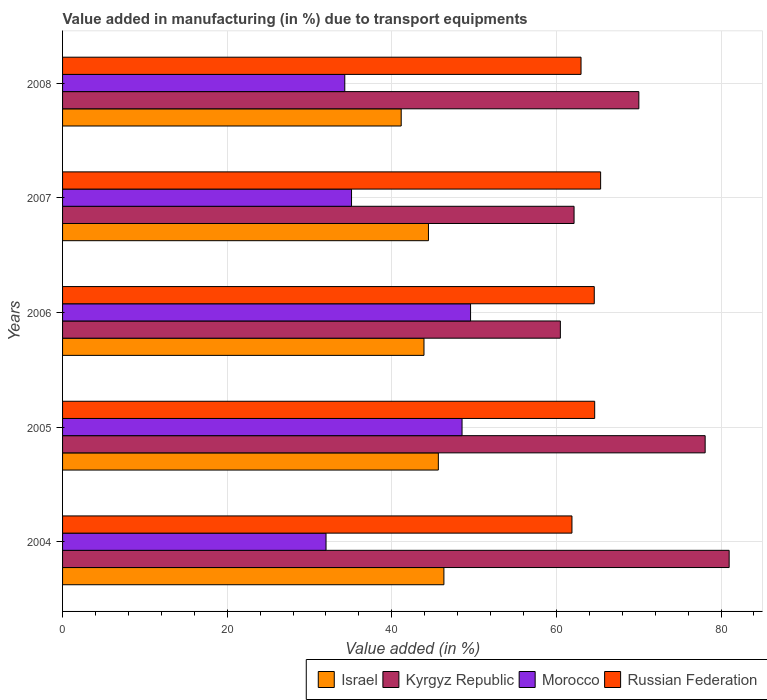Are the number of bars on each tick of the Y-axis equal?
Give a very brief answer. Yes. How many bars are there on the 1st tick from the bottom?
Give a very brief answer. 4. What is the label of the 5th group of bars from the top?
Your answer should be very brief. 2004. In how many cases, is the number of bars for a given year not equal to the number of legend labels?
Give a very brief answer. 0. What is the percentage of value added in manufacturing due to transport equipments in Morocco in 2006?
Provide a short and direct response. 49.57. Across all years, what is the maximum percentage of value added in manufacturing due to transport equipments in Israel?
Ensure brevity in your answer.  46.33. Across all years, what is the minimum percentage of value added in manufacturing due to transport equipments in Russian Federation?
Give a very brief answer. 61.89. What is the total percentage of value added in manufacturing due to transport equipments in Kyrgyz Republic in the graph?
Ensure brevity in your answer.  351.68. What is the difference between the percentage of value added in manufacturing due to transport equipments in Israel in 2007 and that in 2008?
Your response must be concise. 3.31. What is the difference between the percentage of value added in manufacturing due to transport equipments in Russian Federation in 2004 and the percentage of value added in manufacturing due to transport equipments in Kyrgyz Republic in 2005?
Your response must be concise. -16.18. What is the average percentage of value added in manufacturing due to transport equipments in Russian Federation per year?
Give a very brief answer. 63.9. In the year 2004, what is the difference between the percentage of value added in manufacturing due to transport equipments in Morocco and percentage of value added in manufacturing due to transport equipments in Kyrgyz Republic?
Keep it short and to the point. -48.98. What is the ratio of the percentage of value added in manufacturing due to transport equipments in Israel in 2004 to that in 2008?
Provide a succinct answer. 1.13. Is the percentage of value added in manufacturing due to transport equipments in Morocco in 2004 less than that in 2007?
Make the answer very short. Yes. What is the difference between the highest and the second highest percentage of value added in manufacturing due to transport equipments in Morocco?
Offer a terse response. 1.03. What is the difference between the highest and the lowest percentage of value added in manufacturing due to transport equipments in Kyrgyz Republic?
Provide a short and direct response. 20.51. Is the sum of the percentage of value added in manufacturing due to transport equipments in Kyrgyz Republic in 2004 and 2006 greater than the maximum percentage of value added in manufacturing due to transport equipments in Israel across all years?
Your response must be concise. Yes. What does the 1st bar from the top in 2005 represents?
Your response must be concise. Russian Federation. What does the 2nd bar from the bottom in 2008 represents?
Offer a terse response. Kyrgyz Republic. Is it the case that in every year, the sum of the percentage of value added in manufacturing due to transport equipments in Kyrgyz Republic and percentage of value added in manufacturing due to transport equipments in Russian Federation is greater than the percentage of value added in manufacturing due to transport equipments in Israel?
Provide a succinct answer. Yes. Where does the legend appear in the graph?
Offer a very short reply. Bottom right. What is the title of the graph?
Your answer should be compact. Value added in manufacturing (in %) due to transport equipments. Does "Jordan" appear as one of the legend labels in the graph?
Keep it short and to the point. No. What is the label or title of the X-axis?
Provide a succinct answer. Value added (in %). What is the label or title of the Y-axis?
Make the answer very short. Years. What is the Value added (in %) in Israel in 2004?
Offer a terse response. 46.33. What is the Value added (in %) of Kyrgyz Republic in 2004?
Your answer should be compact. 80.98. What is the Value added (in %) of Morocco in 2004?
Provide a succinct answer. 32.01. What is the Value added (in %) in Russian Federation in 2004?
Make the answer very short. 61.89. What is the Value added (in %) in Israel in 2005?
Keep it short and to the point. 45.65. What is the Value added (in %) of Kyrgyz Republic in 2005?
Make the answer very short. 78.07. What is the Value added (in %) in Morocco in 2005?
Your answer should be very brief. 48.53. What is the Value added (in %) in Russian Federation in 2005?
Your answer should be very brief. 64.65. What is the Value added (in %) of Israel in 2006?
Provide a succinct answer. 43.91. What is the Value added (in %) in Kyrgyz Republic in 2006?
Ensure brevity in your answer.  60.48. What is the Value added (in %) in Morocco in 2006?
Keep it short and to the point. 49.57. What is the Value added (in %) of Russian Federation in 2006?
Give a very brief answer. 64.59. What is the Value added (in %) in Israel in 2007?
Ensure brevity in your answer.  44.45. What is the Value added (in %) of Kyrgyz Republic in 2007?
Provide a short and direct response. 62.14. What is the Value added (in %) of Morocco in 2007?
Offer a terse response. 35.11. What is the Value added (in %) of Russian Federation in 2007?
Offer a very short reply. 65.37. What is the Value added (in %) of Israel in 2008?
Offer a terse response. 41.14. What is the Value added (in %) in Kyrgyz Republic in 2008?
Offer a very short reply. 70.01. What is the Value added (in %) in Morocco in 2008?
Make the answer very short. 34.29. What is the Value added (in %) in Russian Federation in 2008?
Offer a very short reply. 62.99. Across all years, what is the maximum Value added (in %) in Israel?
Offer a very short reply. 46.33. Across all years, what is the maximum Value added (in %) in Kyrgyz Republic?
Make the answer very short. 80.98. Across all years, what is the maximum Value added (in %) in Morocco?
Keep it short and to the point. 49.57. Across all years, what is the maximum Value added (in %) in Russian Federation?
Offer a very short reply. 65.37. Across all years, what is the minimum Value added (in %) in Israel?
Keep it short and to the point. 41.14. Across all years, what is the minimum Value added (in %) of Kyrgyz Republic?
Ensure brevity in your answer.  60.48. Across all years, what is the minimum Value added (in %) in Morocco?
Keep it short and to the point. 32.01. Across all years, what is the minimum Value added (in %) of Russian Federation?
Make the answer very short. 61.89. What is the total Value added (in %) of Israel in the graph?
Your answer should be very brief. 221.48. What is the total Value added (in %) of Kyrgyz Republic in the graph?
Ensure brevity in your answer.  351.68. What is the total Value added (in %) in Morocco in the graph?
Provide a succinct answer. 199.5. What is the total Value added (in %) in Russian Federation in the graph?
Give a very brief answer. 319.48. What is the difference between the Value added (in %) of Israel in 2004 and that in 2005?
Keep it short and to the point. 0.67. What is the difference between the Value added (in %) in Kyrgyz Republic in 2004 and that in 2005?
Offer a very short reply. 2.92. What is the difference between the Value added (in %) in Morocco in 2004 and that in 2005?
Make the answer very short. -16.52. What is the difference between the Value added (in %) in Russian Federation in 2004 and that in 2005?
Your response must be concise. -2.76. What is the difference between the Value added (in %) in Israel in 2004 and that in 2006?
Provide a succinct answer. 2.42. What is the difference between the Value added (in %) in Kyrgyz Republic in 2004 and that in 2006?
Offer a very short reply. 20.51. What is the difference between the Value added (in %) of Morocco in 2004 and that in 2006?
Give a very brief answer. -17.56. What is the difference between the Value added (in %) in Russian Federation in 2004 and that in 2006?
Make the answer very short. -2.71. What is the difference between the Value added (in %) of Israel in 2004 and that in 2007?
Offer a very short reply. 1.88. What is the difference between the Value added (in %) of Kyrgyz Republic in 2004 and that in 2007?
Make the answer very short. 18.84. What is the difference between the Value added (in %) of Morocco in 2004 and that in 2007?
Ensure brevity in your answer.  -3.1. What is the difference between the Value added (in %) of Russian Federation in 2004 and that in 2007?
Your response must be concise. -3.48. What is the difference between the Value added (in %) in Israel in 2004 and that in 2008?
Offer a terse response. 5.19. What is the difference between the Value added (in %) in Kyrgyz Republic in 2004 and that in 2008?
Provide a short and direct response. 10.97. What is the difference between the Value added (in %) of Morocco in 2004 and that in 2008?
Keep it short and to the point. -2.28. What is the difference between the Value added (in %) of Russian Federation in 2004 and that in 2008?
Keep it short and to the point. -1.1. What is the difference between the Value added (in %) of Israel in 2005 and that in 2006?
Offer a terse response. 1.75. What is the difference between the Value added (in %) in Kyrgyz Republic in 2005 and that in 2006?
Offer a terse response. 17.59. What is the difference between the Value added (in %) of Morocco in 2005 and that in 2006?
Make the answer very short. -1.03. What is the difference between the Value added (in %) in Russian Federation in 2005 and that in 2006?
Provide a short and direct response. 0.05. What is the difference between the Value added (in %) in Israel in 2005 and that in 2007?
Your answer should be compact. 1.2. What is the difference between the Value added (in %) in Kyrgyz Republic in 2005 and that in 2007?
Ensure brevity in your answer.  15.93. What is the difference between the Value added (in %) of Morocco in 2005 and that in 2007?
Your response must be concise. 13.43. What is the difference between the Value added (in %) of Russian Federation in 2005 and that in 2007?
Offer a very short reply. -0.72. What is the difference between the Value added (in %) in Israel in 2005 and that in 2008?
Your answer should be very brief. 4.51. What is the difference between the Value added (in %) in Kyrgyz Republic in 2005 and that in 2008?
Your answer should be compact. 8.06. What is the difference between the Value added (in %) of Morocco in 2005 and that in 2008?
Your answer should be very brief. 14.25. What is the difference between the Value added (in %) in Russian Federation in 2005 and that in 2008?
Ensure brevity in your answer.  1.66. What is the difference between the Value added (in %) of Israel in 2006 and that in 2007?
Make the answer very short. -0.54. What is the difference between the Value added (in %) of Kyrgyz Republic in 2006 and that in 2007?
Offer a terse response. -1.67. What is the difference between the Value added (in %) in Morocco in 2006 and that in 2007?
Keep it short and to the point. 14.46. What is the difference between the Value added (in %) in Russian Federation in 2006 and that in 2007?
Your response must be concise. -0.77. What is the difference between the Value added (in %) in Israel in 2006 and that in 2008?
Keep it short and to the point. 2.77. What is the difference between the Value added (in %) in Kyrgyz Republic in 2006 and that in 2008?
Your answer should be compact. -9.54. What is the difference between the Value added (in %) in Morocco in 2006 and that in 2008?
Offer a very short reply. 15.28. What is the difference between the Value added (in %) of Russian Federation in 2006 and that in 2008?
Your answer should be compact. 1.61. What is the difference between the Value added (in %) of Israel in 2007 and that in 2008?
Provide a succinct answer. 3.31. What is the difference between the Value added (in %) in Kyrgyz Republic in 2007 and that in 2008?
Offer a very short reply. -7.87. What is the difference between the Value added (in %) of Morocco in 2007 and that in 2008?
Your answer should be compact. 0.82. What is the difference between the Value added (in %) of Russian Federation in 2007 and that in 2008?
Provide a succinct answer. 2.38. What is the difference between the Value added (in %) of Israel in 2004 and the Value added (in %) of Kyrgyz Republic in 2005?
Provide a succinct answer. -31.74. What is the difference between the Value added (in %) in Israel in 2004 and the Value added (in %) in Morocco in 2005?
Make the answer very short. -2.2. What is the difference between the Value added (in %) in Israel in 2004 and the Value added (in %) in Russian Federation in 2005?
Your answer should be compact. -18.32. What is the difference between the Value added (in %) in Kyrgyz Republic in 2004 and the Value added (in %) in Morocco in 2005?
Ensure brevity in your answer.  32.45. What is the difference between the Value added (in %) of Kyrgyz Republic in 2004 and the Value added (in %) of Russian Federation in 2005?
Your answer should be very brief. 16.34. What is the difference between the Value added (in %) of Morocco in 2004 and the Value added (in %) of Russian Federation in 2005?
Your response must be concise. -32.64. What is the difference between the Value added (in %) of Israel in 2004 and the Value added (in %) of Kyrgyz Republic in 2006?
Offer a terse response. -14.15. What is the difference between the Value added (in %) in Israel in 2004 and the Value added (in %) in Morocco in 2006?
Give a very brief answer. -3.24. What is the difference between the Value added (in %) in Israel in 2004 and the Value added (in %) in Russian Federation in 2006?
Offer a very short reply. -18.27. What is the difference between the Value added (in %) in Kyrgyz Republic in 2004 and the Value added (in %) in Morocco in 2006?
Your answer should be compact. 31.42. What is the difference between the Value added (in %) in Kyrgyz Republic in 2004 and the Value added (in %) in Russian Federation in 2006?
Ensure brevity in your answer.  16.39. What is the difference between the Value added (in %) in Morocco in 2004 and the Value added (in %) in Russian Federation in 2006?
Provide a short and direct response. -32.59. What is the difference between the Value added (in %) of Israel in 2004 and the Value added (in %) of Kyrgyz Republic in 2007?
Ensure brevity in your answer.  -15.81. What is the difference between the Value added (in %) of Israel in 2004 and the Value added (in %) of Morocco in 2007?
Your answer should be compact. 11.22. What is the difference between the Value added (in %) in Israel in 2004 and the Value added (in %) in Russian Federation in 2007?
Your answer should be very brief. -19.04. What is the difference between the Value added (in %) of Kyrgyz Republic in 2004 and the Value added (in %) of Morocco in 2007?
Offer a terse response. 45.88. What is the difference between the Value added (in %) of Kyrgyz Republic in 2004 and the Value added (in %) of Russian Federation in 2007?
Your answer should be very brief. 15.62. What is the difference between the Value added (in %) in Morocco in 2004 and the Value added (in %) in Russian Federation in 2007?
Your answer should be compact. -33.36. What is the difference between the Value added (in %) of Israel in 2004 and the Value added (in %) of Kyrgyz Republic in 2008?
Make the answer very short. -23.68. What is the difference between the Value added (in %) of Israel in 2004 and the Value added (in %) of Morocco in 2008?
Your response must be concise. 12.04. What is the difference between the Value added (in %) in Israel in 2004 and the Value added (in %) in Russian Federation in 2008?
Provide a succinct answer. -16.66. What is the difference between the Value added (in %) of Kyrgyz Republic in 2004 and the Value added (in %) of Morocco in 2008?
Make the answer very short. 46.7. What is the difference between the Value added (in %) of Kyrgyz Republic in 2004 and the Value added (in %) of Russian Federation in 2008?
Provide a succinct answer. 18. What is the difference between the Value added (in %) of Morocco in 2004 and the Value added (in %) of Russian Federation in 2008?
Keep it short and to the point. -30.98. What is the difference between the Value added (in %) of Israel in 2005 and the Value added (in %) of Kyrgyz Republic in 2006?
Offer a terse response. -14.82. What is the difference between the Value added (in %) in Israel in 2005 and the Value added (in %) in Morocco in 2006?
Your answer should be compact. -3.91. What is the difference between the Value added (in %) of Israel in 2005 and the Value added (in %) of Russian Federation in 2006?
Ensure brevity in your answer.  -18.94. What is the difference between the Value added (in %) of Kyrgyz Republic in 2005 and the Value added (in %) of Morocco in 2006?
Your answer should be compact. 28.5. What is the difference between the Value added (in %) in Kyrgyz Republic in 2005 and the Value added (in %) in Russian Federation in 2006?
Make the answer very short. 13.47. What is the difference between the Value added (in %) of Morocco in 2005 and the Value added (in %) of Russian Federation in 2006?
Make the answer very short. -16.06. What is the difference between the Value added (in %) in Israel in 2005 and the Value added (in %) in Kyrgyz Republic in 2007?
Provide a short and direct response. -16.49. What is the difference between the Value added (in %) in Israel in 2005 and the Value added (in %) in Morocco in 2007?
Your response must be concise. 10.55. What is the difference between the Value added (in %) in Israel in 2005 and the Value added (in %) in Russian Federation in 2007?
Your response must be concise. -19.71. What is the difference between the Value added (in %) of Kyrgyz Republic in 2005 and the Value added (in %) of Morocco in 2007?
Provide a succinct answer. 42.96. What is the difference between the Value added (in %) of Kyrgyz Republic in 2005 and the Value added (in %) of Russian Federation in 2007?
Provide a succinct answer. 12.7. What is the difference between the Value added (in %) of Morocco in 2005 and the Value added (in %) of Russian Federation in 2007?
Provide a short and direct response. -16.84. What is the difference between the Value added (in %) of Israel in 2005 and the Value added (in %) of Kyrgyz Republic in 2008?
Give a very brief answer. -24.36. What is the difference between the Value added (in %) of Israel in 2005 and the Value added (in %) of Morocco in 2008?
Offer a very short reply. 11.37. What is the difference between the Value added (in %) of Israel in 2005 and the Value added (in %) of Russian Federation in 2008?
Your response must be concise. -17.34. What is the difference between the Value added (in %) in Kyrgyz Republic in 2005 and the Value added (in %) in Morocco in 2008?
Offer a terse response. 43.78. What is the difference between the Value added (in %) in Kyrgyz Republic in 2005 and the Value added (in %) in Russian Federation in 2008?
Provide a succinct answer. 15.08. What is the difference between the Value added (in %) of Morocco in 2005 and the Value added (in %) of Russian Federation in 2008?
Provide a short and direct response. -14.46. What is the difference between the Value added (in %) in Israel in 2006 and the Value added (in %) in Kyrgyz Republic in 2007?
Offer a very short reply. -18.23. What is the difference between the Value added (in %) of Israel in 2006 and the Value added (in %) of Morocco in 2007?
Keep it short and to the point. 8.8. What is the difference between the Value added (in %) in Israel in 2006 and the Value added (in %) in Russian Federation in 2007?
Your response must be concise. -21.46. What is the difference between the Value added (in %) in Kyrgyz Republic in 2006 and the Value added (in %) in Morocco in 2007?
Offer a terse response. 25.37. What is the difference between the Value added (in %) of Kyrgyz Republic in 2006 and the Value added (in %) of Russian Federation in 2007?
Provide a succinct answer. -4.89. What is the difference between the Value added (in %) of Morocco in 2006 and the Value added (in %) of Russian Federation in 2007?
Keep it short and to the point. -15.8. What is the difference between the Value added (in %) of Israel in 2006 and the Value added (in %) of Kyrgyz Republic in 2008?
Your answer should be compact. -26.1. What is the difference between the Value added (in %) of Israel in 2006 and the Value added (in %) of Morocco in 2008?
Your response must be concise. 9.62. What is the difference between the Value added (in %) in Israel in 2006 and the Value added (in %) in Russian Federation in 2008?
Offer a terse response. -19.08. What is the difference between the Value added (in %) in Kyrgyz Republic in 2006 and the Value added (in %) in Morocco in 2008?
Offer a terse response. 26.19. What is the difference between the Value added (in %) of Kyrgyz Republic in 2006 and the Value added (in %) of Russian Federation in 2008?
Your response must be concise. -2.51. What is the difference between the Value added (in %) in Morocco in 2006 and the Value added (in %) in Russian Federation in 2008?
Give a very brief answer. -13.42. What is the difference between the Value added (in %) in Israel in 2007 and the Value added (in %) in Kyrgyz Republic in 2008?
Keep it short and to the point. -25.56. What is the difference between the Value added (in %) in Israel in 2007 and the Value added (in %) in Morocco in 2008?
Keep it short and to the point. 10.16. What is the difference between the Value added (in %) in Israel in 2007 and the Value added (in %) in Russian Federation in 2008?
Your answer should be very brief. -18.54. What is the difference between the Value added (in %) in Kyrgyz Republic in 2007 and the Value added (in %) in Morocco in 2008?
Offer a terse response. 27.86. What is the difference between the Value added (in %) in Kyrgyz Republic in 2007 and the Value added (in %) in Russian Federation in 2008?
Make the answer very short. -0.85. What is the difference between the Value added (in %) in Morocco in 2007 and the Value added (in %) in Russian Federation in 2008?
Give a very brief answer. -27.88. What is the average Value added (in %) in Israel per year?
Ensure brevity in your answer.  44.3. What is the average Value added (in %) of Kyrgyz Republic per year?
Your answer should be compact. 70.34. What is the average Value added (in %) of Morocco per year?
Your answer should be compact. 39.9. What is the average Value added (in %) in Russian Federation per year?
Your answer should be compact. 63.9. In the year 2004, what is the difference between the Value added (in %) in Israel and Value added (in %) in Kyrgyz Republic?
Keep it short and to the point. -34.66. In the year 2004, what is the difference between the Value added (in %) of Israel and Value added (in %) of Morocco?
Provide a succinct answer. 14.32. In the year 2004, what is the difference between the Value added (in %) in Israel and Value added (in %) in Russian Federation?
Make the answer very short. -15.56. In the year 2004, what is the difference between the Value added (in %) of Kyrgyz Republic and Value added (in %) of Morocco?
Ensure brevity in your answer.  48.98. In the year 2004, what is the difference between the Value added (in %) in Kyrgyz Republic and Value added (in %) in Russian Federation?
Keep it short and to the point. 19.1. In the year 2004, what is the difference between the Value added (in %) in Morocco and Value added (in %) in Russian Federation?
Offer a very short reply. -29.88. In the year 2005, what is the difference between the Value added (in %) in Israel and Value added (in %) in Kyrgyz Republic?
Offer a very short reply. -32.41. In the year 2005, what is the difference between the Value added (in %) of Israel and Value added (in %) of Morocco?
Offer a very short reply. -2.88. In the year 2005, what is the difference between the Value added (in %) in Israel and Value added (in %) in Russian Federation?
Your response must be concise. -18.99. In the year 2005, what is the difference between the Value added (in %) in Kyrgyz Republic and Value added (in %) in Morocco?
Give a very brief answer. 29.54. In the year 2005, what is the difference between the Value added (in %) in Kyrgyz Republic and Value added (in %) in Russian Federation?
Offer a terse response. 13.42. In the year 2005, what is the difference between the Value added (in %) in Morocco and Value added (in %) in Russian Federation?
Give a very brief answer. -16.11. In the year 2006, what is the difference between the Value added (in %) of Israel and Value added (in %) of Kyrgyz Republic?
Your response must be concise. -16.57. In the year 2006, what is the difference between the Value added (in %) in Israel and Value added (in %) in Morocco?
Your answer should be very brief. -5.66. In the year 2006, what is the difference between the Value added (in %) of Israel and Value added (in %) of Russian Federation?
Your answer should be very brief. -20.69. In the year 2006, what is the difference between the Value added (in %) in Kyrgyz Republic and Value added (in %) in Morocco?
Ensure brevity in your answer.  10.91. In the year 2006, what is the difference between the Value added (in %) in Kyrgyz Republic and Value added (in %) in Russian Federation?
Offer a very short reply. -4.12. In the year 2006, what is the difference between the Value added (in %) of Morocco and Value added (in %) of Russian Federation?
Your answer should be very brief. -15.03. In the year 2007, what is the difference between the Value added (in %) in Israel and Value added (in %) in Kyrgyz Republic?
Offer a very short reply. -17.69. In the year 2007, what is the difference between the Value added (in %) in Israel and Value added (in %) in Morocco?
Offer a very short reply. 9.35. In the year 2007, what is the difference between the Value added (in %) of Israel and Value added (in %) of Russian Federation?
Your answer should be compact. -20.92. In the year 2007, what is the difference between the Value added (in %) of Kyrgyz Republic and Value added (in %) of Morocco?
Your answer should be very brief. 27.04. In the year 2007, what is the difference between the Value added (in %) in Kyrgyz Republic and Value added (in %) in Russian Federation?
Your response must be concise. -3.23. In the year 2007, what is the difference between the Value added (in %) in Morocco and Value added (in %) in Russian Federation?
Offer a very short reply. -30.26. In the year 2008, what is the difference between the Value added (in %) of Israel and Value added (in %) of Kyrgyz Republic?
Provide a short and direct response. -28.87. In the year 2008, what is the difference between the Value added (in %) of Israel and Value added (in %) of Morocco?
Your answer should be compact. 6.85. In the year 2008, what is the difference between the Value added (in %) in Israel and Value added (in %) in Russian Federation?
Your answer should be compact. -21.85. In the year 2008, what is the difference between the Value added (in %) in Kyrgyz Republic and Value added (in %) in Morocco?
Provide a succinct answer. 35.72. In the year 2008, what is the difference between the Value added (in %) of Kyrgyz Republic and Value added (in %) of Russian Federation?
Provide a short and direct response. 7.02. In the year 2008, what is the difference between the Value added (in %) of Morocco and Value added (in %) of Russian Federation?
Provide a short and direct response. -28.7. What is the ratio of the Value added (in %) of Israel in 2004 to that in 2005?
Offer a terse response. 1.01. What is the ratio of the Value added (in %) in Kyrgyz Republic in 2004 to that in 2005?
Provide a short and direct response. 1.04. What is the ratio of the Value added (in %) in Morocco in 2004 to that in 2005?
Keep it short and to the point. 0.66. What is the ratio of the Value added (in %) of Russian Federation in 2004 to that in 2005?
Make the answer very short. 0.96. What is the ratio of the Value added (in %) in Israel in 2004 to that in 2006?
Your response must be concise. 1.06. What is the ratio of the Value added (in %) in Kyrgyz Republic in 2004 to that in 2006?
Provide a short and direct response. 1.34. What is the ratio of the Value added (in %) in Morocco in 2004 to that in 2006?
Ensure brevity in your answer.  0.65. What is the ratio of the Value added (in %) in Russian Federation in 2004 to that in 2006?
Keep it short and to the point. 0.96. What is the ratio of the Value added (in %) in Israel in 2004 to that in 2007?
Provide a short and direct response. 1.04. What is the ratio of the Value added (in %) in Kyrgyz Republic in 2004 to that in 2007?
Ensure brevity in your answer.  1.3. What is the ratio of the Value added (in %) of Morocco in 2004 to that in 2007?
Your response must be concise. 0.91. What is the ratio of the Value added (in %) of Russian Federation in 2004 to that in 2007?
Give a very brief answer. 0.95. What is the ratio of the Value added (in %) in Israel in 2004 to that in 2008?
Your answer should be very brief. 1.13. What is the ratio of the Value added (in %) of Kyrgyz Republic in 2004 to that in 2008?
Your answer should be very brief. 1.16. What is the ratio of the Value added (in %) in Morocco in 2004 to that in 2008?
Your answer should be compact. 0.93. What is the ratio of the Value added (in %) of Russian Federation in 2004 to that in 2008?
Give a very brief answer. 0.98. What is the ratio of the Value added (in %) in Israel in 2005 to that in 2006?
Offer a terse response. 1.04. What is the ratio of the Value added (in %) of Kyrgyz Republic in 2005 to that in 2006?
Ensure brevity in your answer.  1.29. What is the ratio of the Value added (in %) in Morocco in 2005 to that in 2006?
Give a very brief answer. 0.98. What is the ratio of the Value added (in %) of Russian Federation in 2005 to that in 2006?
Your answer should be very brief. 1. What is the ratio of the Value added (in %) of Kyrgyz Republic in 2005 to that in 2007?
Your response must be concise. 1.26. What is the ratio of the Value added (in %) of Morocco in 2005 to that in 2007?
Make the answer very short. 1.38. What is the ratio of the Value added (in %) in Russian Federation in 2005 to that in 2007?
Your response must be concise. 0.99. What is the ratio of the Value added (in %) in Israel in 2005 to that in 2008?
Give a very brief answer. 1.11. What is the ratio of the Value added (in %) in Kyrgyz Republic in 2005 to that in 2008?
Keep it short and to the point. 1.12. What is the ratio of the Value added (in %) of Morocco in 2005 to that in 2008?
Your response must be concise. 1.42. What is the ratio of the Value added (in %) of Russian Federation in 2005 to that in 2008?
Keep it short and to the point. 1.03. What is the ratio of the Value added (in %) in Israel in 2006 to that in 2007?
Your answer should be compact. 0.99. What is the ratio of the Value added (in %) in Kyrgyz Republic in 2006 to that in 2007?
Offer a terse response. 0.97. What is the ratio of the Value added (in %) of Morocco in 2006 to that in 2007?
Make the answer very short. 1.41. What is the ratio of the Value added (in %) in Israel in 2006 to that in 2008?
Provide a short and direct response. 1.07. What is the ratio of the Value added (in %) in Kyrgyz Republic in 2006 to that in 2008?
Your answer should be compact. 0.86. What is the ratio of the Value added (in %) of Morocco in 2006 to that in 2008?
Offer a very short reply. 1.45. What is the ratio of the Value added (in %) of Russian Federation in 2006 to that in 2008?
Offer a terse response. 1.03. What is the ratio of the Value added (in %) in Israel in 2007 to that in 2008?
Offer a terse response. 1.08. What is the ratio of the Value added (in %) in Kyrgyz Republic in 2007 to that in 2008?
Provide a short and direct response. 0.89. What is the ratio of the Value added (in %) in Morocco in 2007 to that in 2008?
Provide a succinct answer. 1.02. What is the ratio of the Value added (in %) of Russian Federation in 2007 to that in 2008?
Provide a short and direct response. 1.04. What is the difference between the highest and the second highest Value added (in %) of Israel?
Keep it short and to the point. 0.67. What is the difference between the highest and the second highest Value added (in %) of Kyrgyz Republic?
Ensure brevity in your answer.  2.92. What is the difference between the highest and the second highest Value added (in %) of Morocco?
Ensure brevity in your answer.  1.03. What is the difference between the highest and the second highest Value added (in %) in Russian Federation?
Give a very brief answer. 0.72. What is the difference between the highest and the lowest Value added (in %) of Israel?
Give a very brief answer. 5.19. What is the difference between the highest and the lowest Value added (in %) of Kyrgyz Republic?
Provide a short and direct response. 20.51. What is the difference between the highest and the lowest Value added (in %) of Morocco?
Your answer should be very brief. 17.56. What is the difference between the highest and the lowest Value added (in %) in Russian Federation?
Keep it short and to the point. 3.48. 